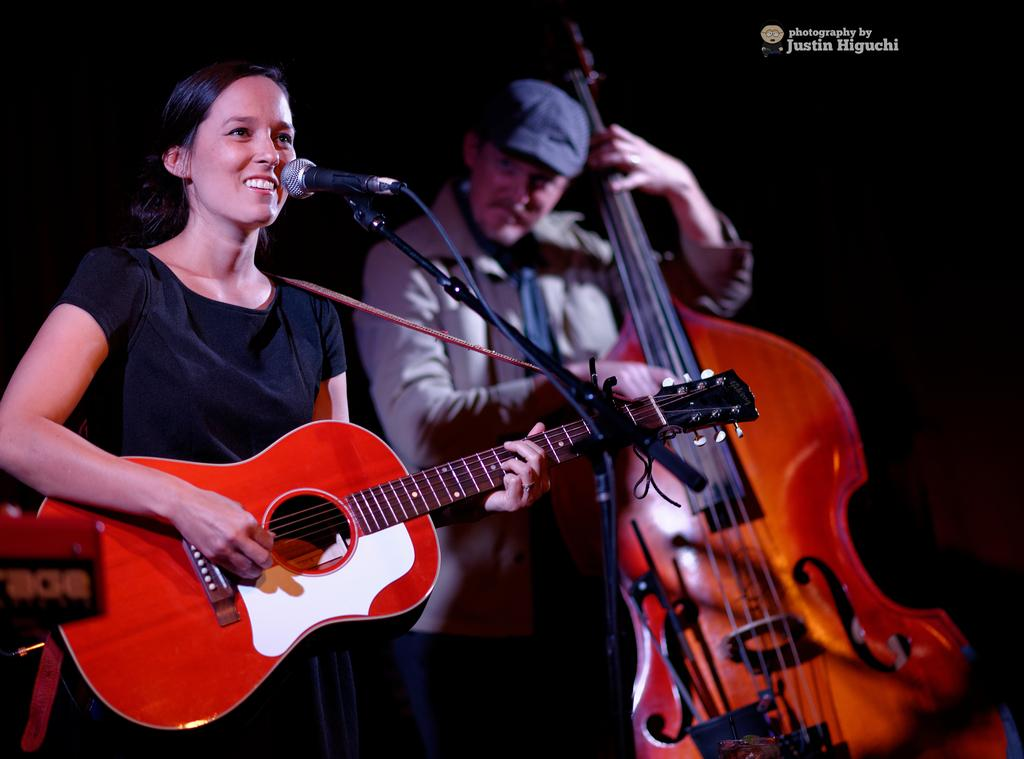Who is the main subject in the image? There is a girl in the image. What is the girl doing in the image? The girl is playing a guitar and singing on a microphone. Are there any other people in the image? Yes, there is a woman in the image. What is the woman doing in the image? The woman is playing a violin. What type of yoke is the queen holding in the image? There is no queen or yoke present in the image. 